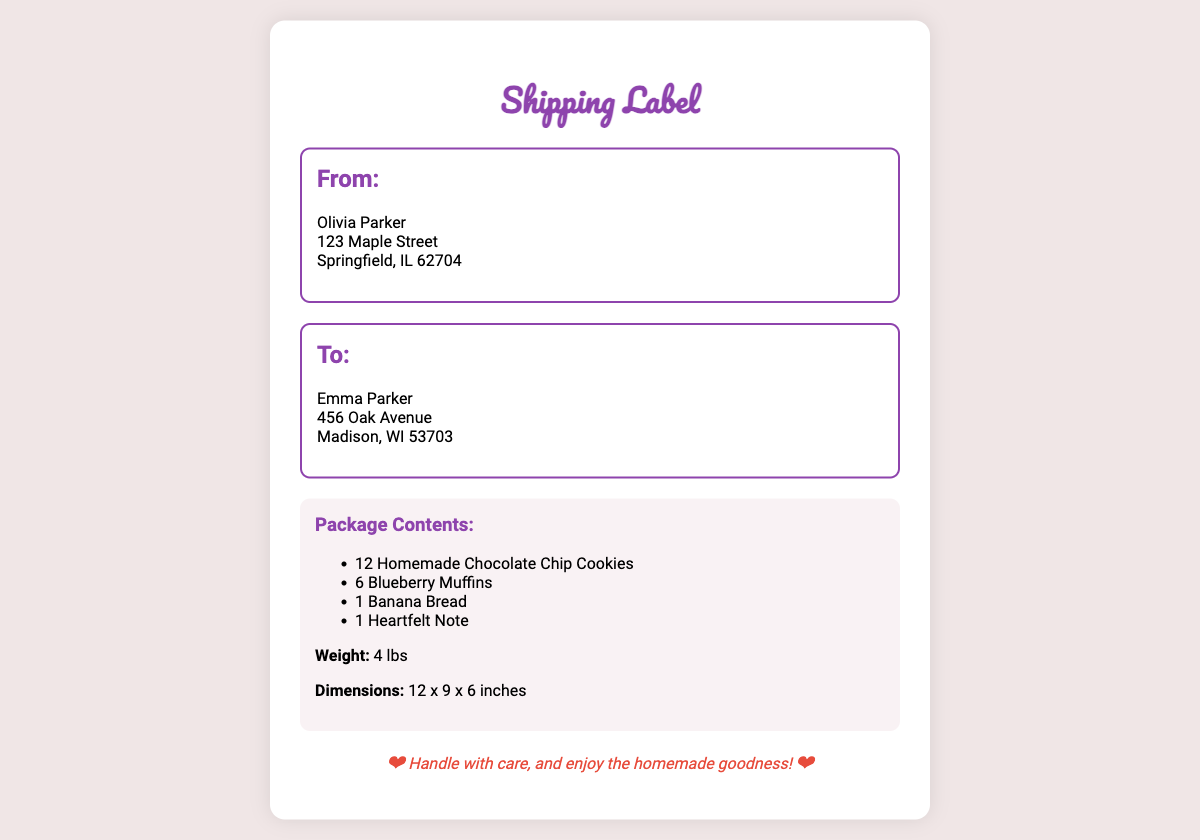What is the sender's name? The sender is named Olivia Parker, which is mentioned in the "From" section of the document.
Answer: Olivia Parker What is the recipient's address? The recipient's address includes the name, street address, city, state, and zip code, which is 456 Oak Avenue, Madison, WI 53703.
Answer: 456 Oak Avenue, Madison, WI 53703 How many chocolate chip cookies are in the package? The document lists 12 homemade chocolate chip cookies as part of the package contents.
Answer: 12 What is the total weight of the package? The weight of the package is specified as 4 lbs in the package information.
Answer: 4 lbs What are the dimensions of the package? The dimensions of the package are provided as 12 x 9 x 6 inches, which are listed in the package information.
Answer: 12 x 9 x 6 inches What type of baked good is included besides cookies and muffins? The package includes one item that is different from cookies and muffins, which is banana bread.
Answer: Banana Bread What special instruction is given for the package? The special instruction emphasizes handling the package with care and enjoying the homemade goodness, as detailed in the special instructions section.
Answer: Handle with care, and enjoy the homemade goodness! What is the significance of the heart symbols in the document? The heart symbols are used to convey warmth and love in the message, enhancing the heartfelt nature of the package.
Answer: Heartfelt sentiment 